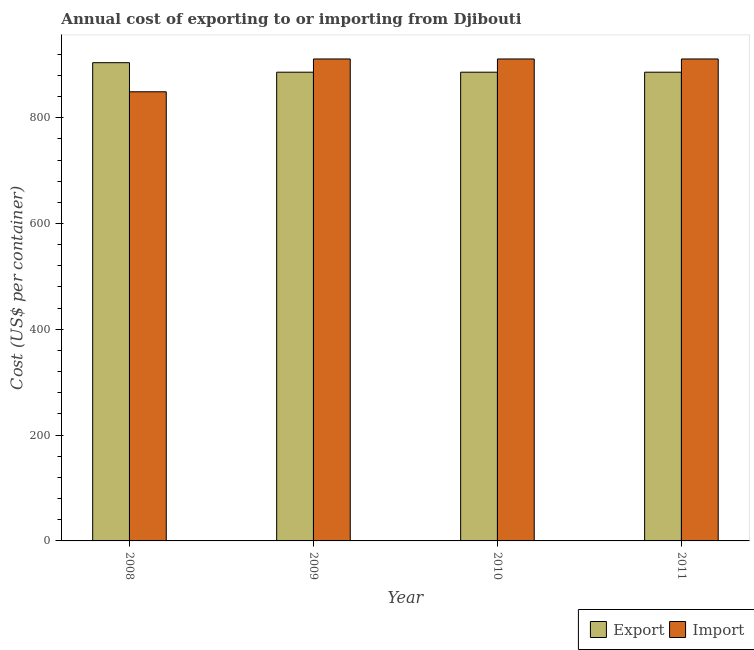How many groups of bars are there?
Give a very brief answer. 4. Are the number of bars per tick equal to the number of legend labels?
Provide a short and direct response. Yes. Are the number of bars on each tick of the X-axis equal?
Keep it short and to the point. Yes. How many bars are there on the 3rd tick from the right?
Provide a succinct answer. 2. In how many cases, is the number of bars for a given year not equal to the number of legend labels?
Keep it short and to the point. 0. What is the import cost in 2011?
Your response must be concise. 911. Across all years, what is the maximum import cost?
Offer a very short reply. 911. Across all years, what is the minimum export cost?
Give a very brief answer. 886. In which year was the import cost maximum?
Keep it short and to the point. 2009. What is the total export cost in the graph?
Ensure brevity in your answer.  3562. What is the difference between the export cost in 2008 and that in 2011?
Provide a short and direct response. 18. What is the difference between the import cost in 2011 and the export cost in 2008?
Make the answer very short. 62. What is the average export cost per year?
Ensure brevity in your answer.  890.5. In the year 2010, what is the difference between the import cost and export cost?
Keep it short and to the point. 0. What is the ratio of the export cost in 2009 to that in 2011?
Provide a succinct answer. 1. Is the import cost in 2008 less than that in 2009?
Keep it short and to the point. Yes. Is the difference between the export cost in 2009 and 2011 greater than the difference between the import cost in 2009 and 2011?
Provide a succinct answer. No. What is the difference between the highest and the lowest import cost?
Ensure brevity in your answer.  62. Is the sum of the export cost in 2010 and 2011 greater than the maximum import cost across all years?
Offer a very short reply. Yes. What does the 2nd bar from the left in 2011 represents?
Provide a succinct answer. Import. What does the 1st bar from the right in 2008 represents?
Provide a short and direct response. Import. How many bars are there?
Ensure brevity in your answer.  8. How many years are there in the graph?
Keep it short and to the point. 4. Are the values on the major ticks of Y-axis written in scientific E-notation?
Offer a terse response. No. Does the graph contain any zero values?
Give a very brief answer. No. Does the graph contain grids?
Offer a very short reply. No. Where does the legend appear in the graph?
Provide a short and direct response. Bottom right. How many legend labels are there?
Provide a short and direct response. 2. What is the title of the graph?
Give a very brief answer. Annual cost of exporting to or importing from Djibouti. What is the label or title of the Y-axis?
Your answer should be very brief. Cost (US$ per container). What is the Cost (US$ per container) of Export in 2008?
Offer a terse response. 904. What is the Cost (US$ per container) of Import in 2008?
Your answer should be compact. 849. What is the Cost (US$ per container) of Export in 2009?
Your answer should be very brief. 886. What is the Cost (US$ per container) of Import in 2009?
Offer a very short reply. 911. What is the Cost (US$ per container) of Export in 2010?
Offer a terse response. 886. What is the Cost (US$ per container) in Import in 2010?
Provide a short and direct response. 911. What is the Cost (US$ per container) of Export in 2011?
Ensure brevity in your answer.  886. What is the Cost (US$ per container) of Import in 2011?
Offer a terse response. 911. Across all years, what is the maximum Cost (US$ per container) in Export?
Offer a very short reply. 904. Across all years, what is the maximum Cost (US$ per container) in Import?
Make the answer very short. 911. Across all years, what is the minimum Cost (US$ per container) of Export?
Offer a very short reply. 886. Across all years, what is the minimum Cost (US$ per container) in Import?
Make the answer very short. 849. What is the total Cost (US$ per container) of Export in the graph?
Make the answer very short. 3562. What is the total Cost (US$ per container) of Import in the graph?
Your response must be concise. 3582. What is the difference between the Cost (US$ per container) of Import in 2008 and that in 2009?
Keep it short and to the point. -62. What is the difference between the Cost (US$ per container) in Export in 2008 and that in 2010?
Offer a terse response. 18. What is the difference between the Cost (US$ per container) of Import in 2008 and that in 2010?
Make the answer very short. -62. What is the difference between the Cost (US$ per container) in Import in 2008 and that in 2011?
Provide a short and direct response. -62. What is the difference between the Cost (US$ per container) in Export in 2009 and that in 2010?
Provide a short and direct response. 0. What is the difference between the Cost (US$ per container) in Import in 2009 and that in 2010?
Provide a succinct answer. 0. What is the difference between the Cost (US$ per container) of Export in 2009 and that in 2011?
Offer a terse response. 0. What is the difference between the Cost (US$ per container) of Import in 2009 and that in 2011?
Offer a terse response. 0. What is the difference between the Cost (US$ per container) of Export in 2008 and the Cost (US$ per container) of Import in 2010?
Give a very brief answer. -7. What is the difference between the Cost (US$ per container) of Export in 2008 and the Cost (US$ per container) of Import in 2011?
Your answer should be very brief. -7. What is the difference between the Cost (US$ per container) of Export in 2009 and the Cost (US$ per container) of Import in 2010?
Give a very brief answer. -25. What is the average Cost (US$ per container) in Export per year?
Offer a terse response. 890.5. What is the average Cost (US$ per container) of Import per year?
Make the answer very short. 895.5. In the year 2008, what is the difference between the Cost (US$ per container) of Export and Cost (US$ per container) of Import?
Ensure brevity in your answer.  55. What is the ratio of the Cost (US$ per container) in Export in 2008 to that in 2009?
Make the answer very short. 1.02. What is the ratio of the Cost (US$ per container) of Import in 2008 to that in 2009?
Give a very brief answer. 0.93. What is the ratio of the Cost (US$ per container) in Export in 2008 to that in 2010?
Make the answer very short. 1.02. What is the ratio of the Cost (US$ per container) of Import in 2008 to that in 2010?
Your answer should be very brief. 0.93. What is the ratio of the Cost (US$ per container) of Export in 2008 to that in 2011?
Offer a very short reply. 1.02. What is the ratio of the Cost (US$ per container) in Import in 2008 to that in 2011?
Provide a short and direct response. 0.93. What is the difference between the highest and the lowest Cost (US$ per container) of Import?
Make the answer very short. 62. 